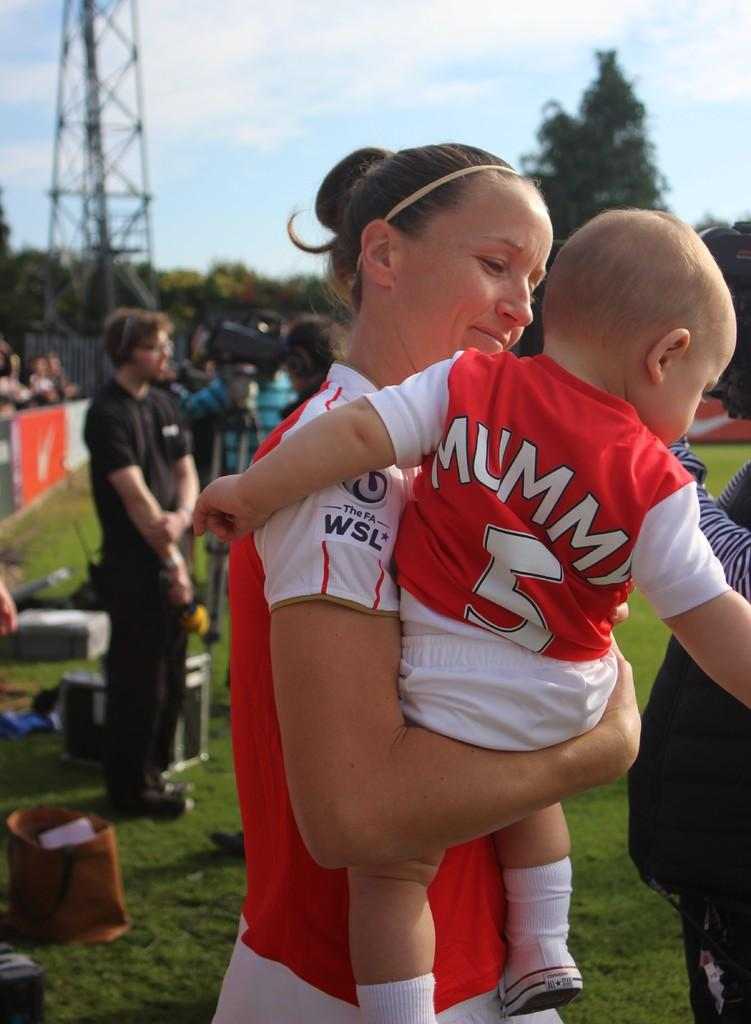<image>
Offer a succinct explanation of the picture presented. A mother holds her child with a jersey saying Mummy and the number 5 